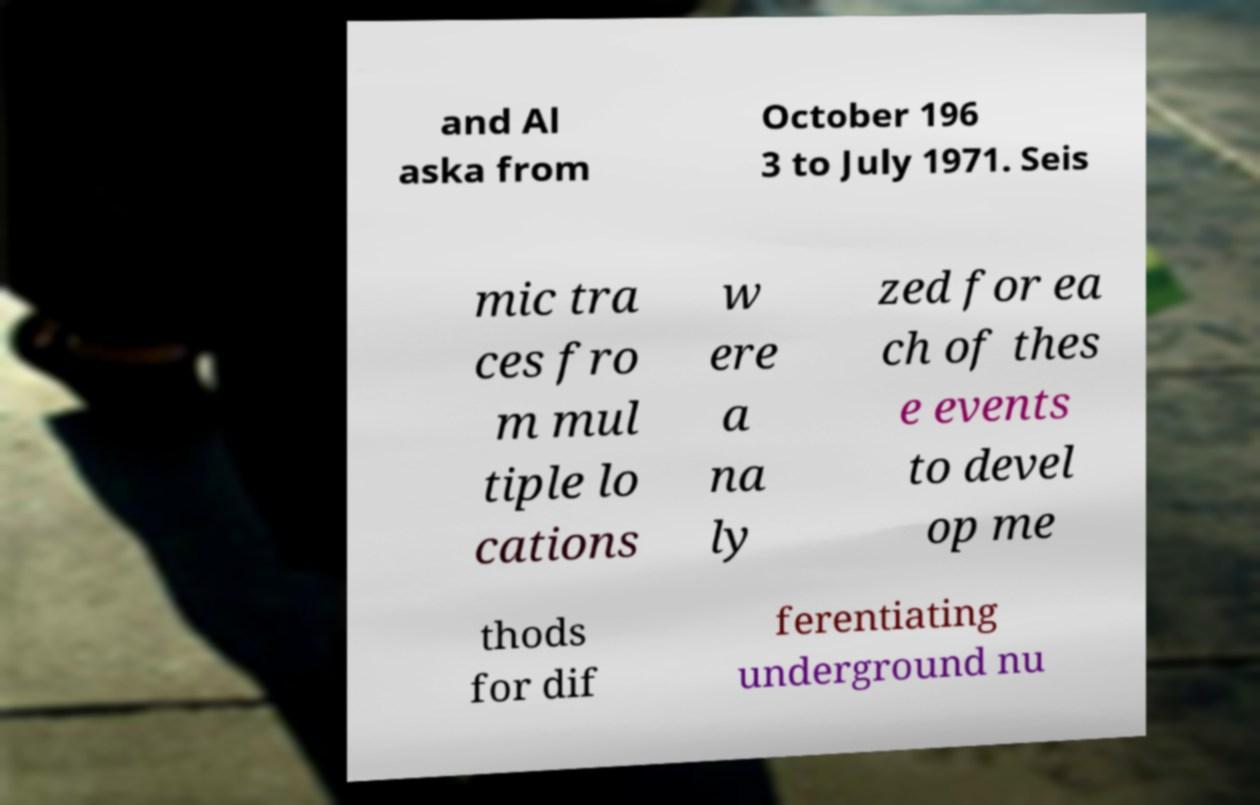Can you accurately transcribe the text from the provided image for me? and Al aska from October 196 3 to July 1971. Seis mic tra ces fro m mul tiple lo cations w ere a na ly zed for ea ch of thes e events to devel op me thods for dif ferentiating underground nu 